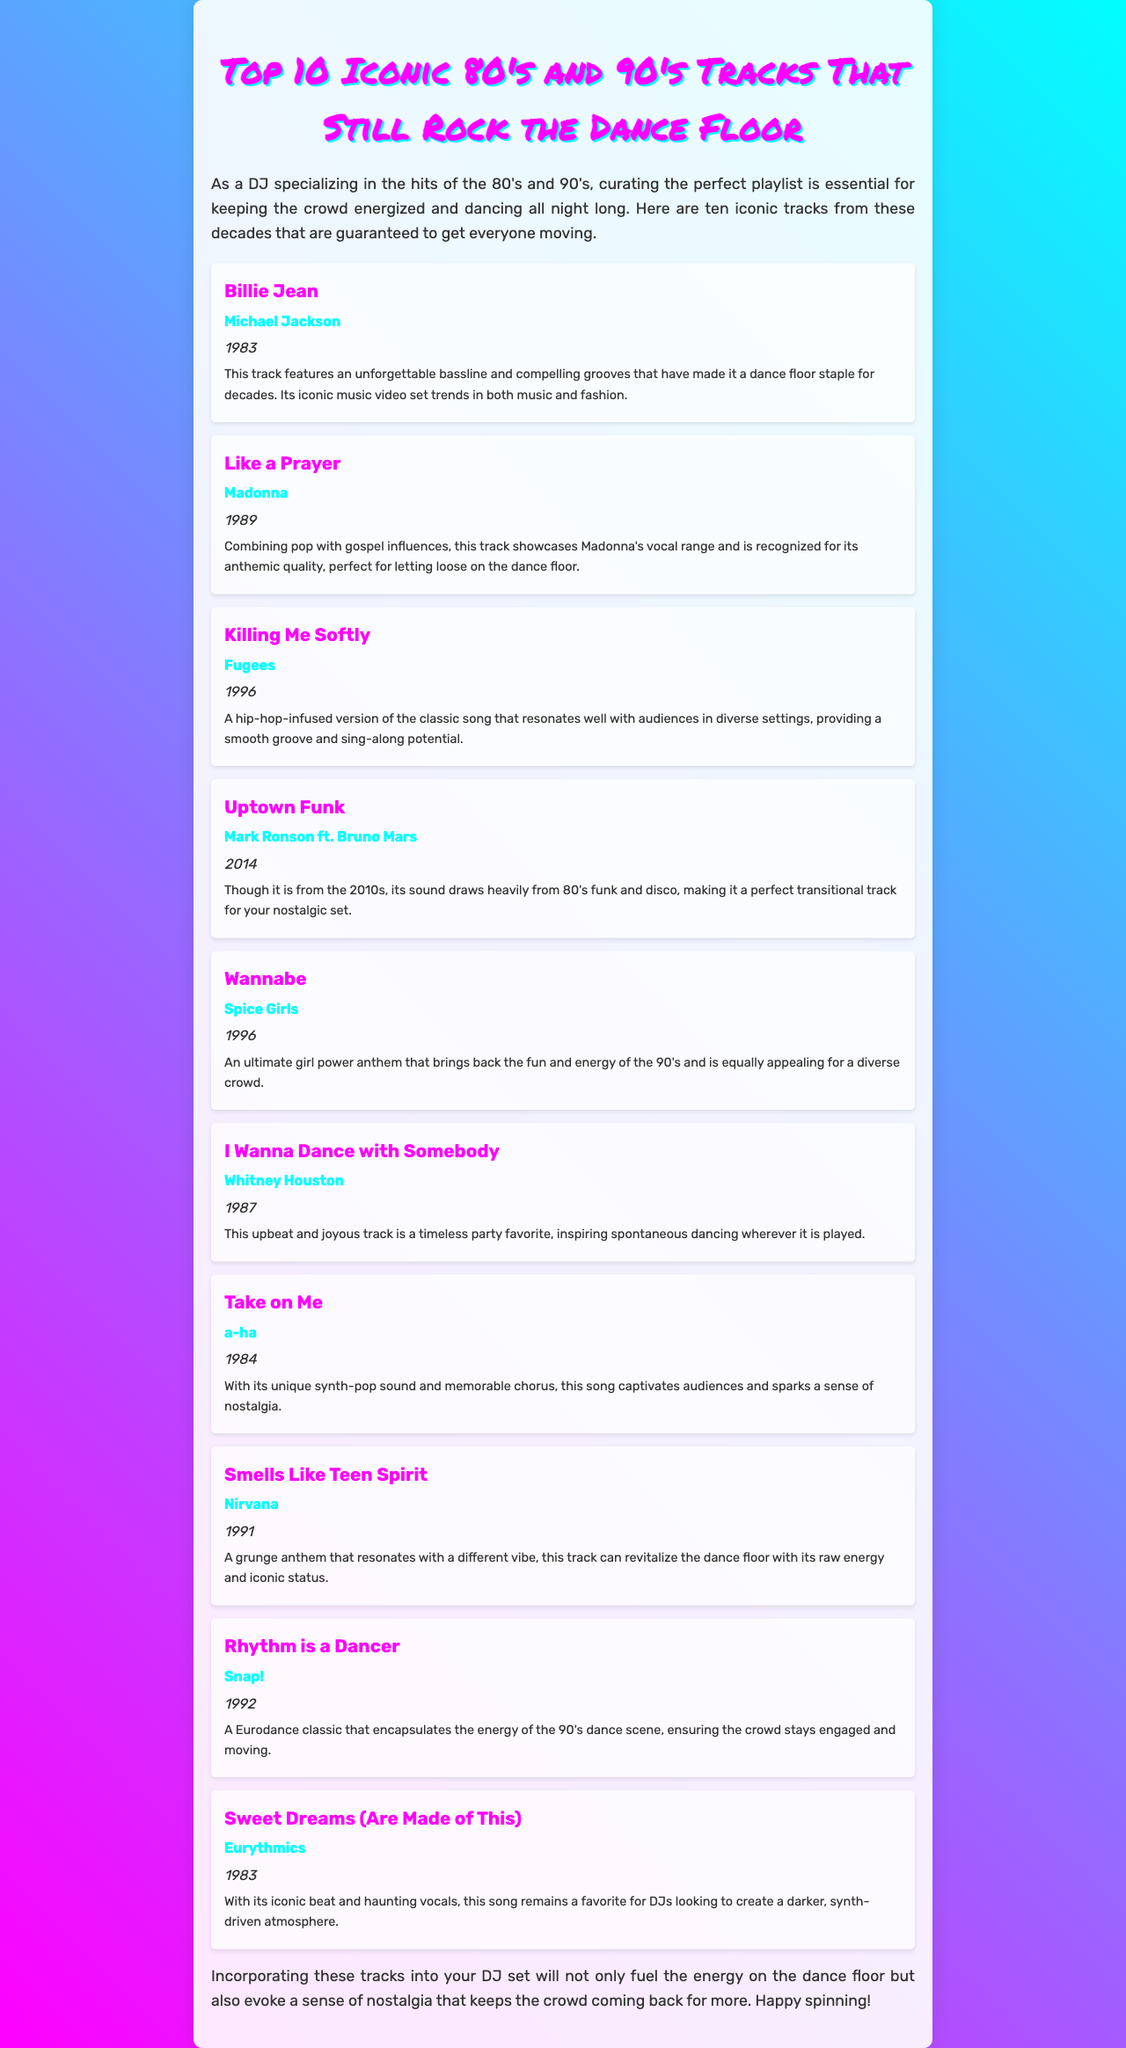what is the first track listed? The first track in the list is "Billie Jean," which is mentioned at the top of the track list.
Answer: Billie Jean who is the artist of "Like a Prayer"? The artist of "Like a Prayer" is specified right after the track title in the document.
Answer: Madonna what year was "Killing Me Softly" released? The year of release for "Killing Me Softly" is stated directly under the track title.
Answer: 1996 which track is described as a "girl power anthem"? The document explicitly describes "Wannabe" as the "ultimate girl power anthem."
Answer: Wannabe how many tracks are from the 90's in the list? By counting the tracks, we can determine how many were released in the 90's based on the years provided.
Answer: 4 which track's notes mention an "unforgettable bassline"? The notes for "Billie Jean" highlight its "unforgettable bassline."
Answer: Billie Jean what is the primary genre of "Uptown Funk"? The document states that "Uptown Funk" draws heavily from 80's funk and disco, indicating its primary genres.
Answer: Funk and Disco what type of atmosphere does "Sweet Dreams (Are Made of This)" create? The notes suggest that "Sweet Dreams (Are Made of This)" is for creating a darker, synth-driven atmosphere.
Answer: Darker, synth-driven atmosphere how many tracks were released in the 80's? The document includes a list of tracks, allowing us to count how many were from the 80's based on their release years.
Answer: 5 